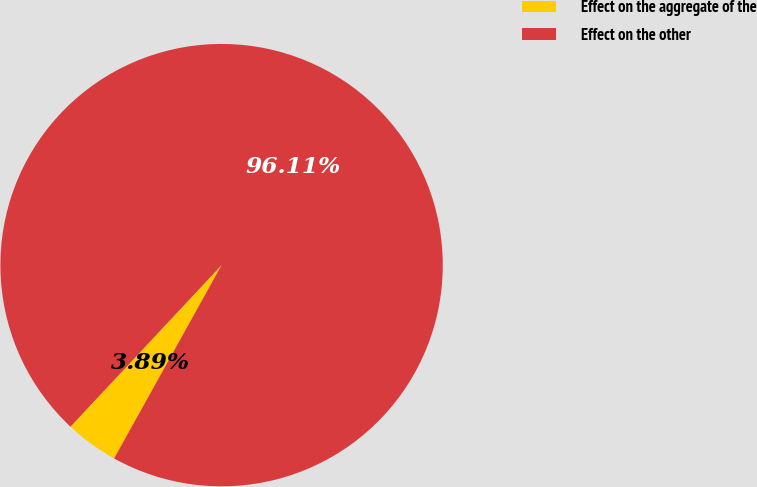<chart> <loc_0><loc_0><loc_500><loc_500><pie_chart><fcel>Effect on the aggregate of the<fcel>Effect on the other<nl><fcel>3.89%<fcel>96.11%<nl></chart> 